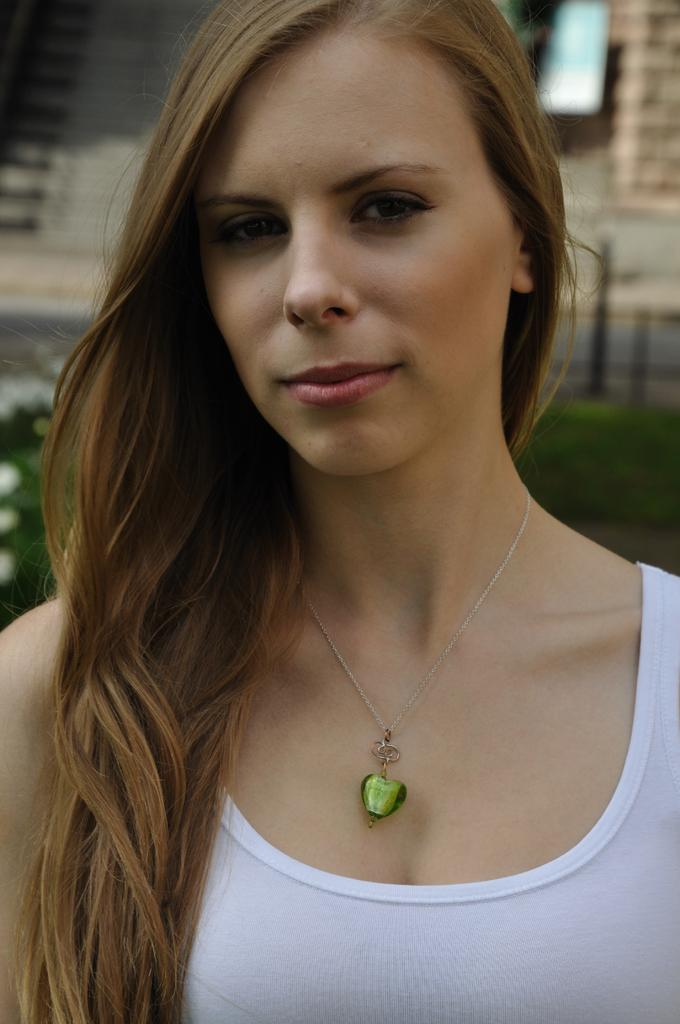Who is present in the image? There is a woman in the image. What is the woman doing in the image? The woman is standing in the image. What is the woman's facial expression in the image? The woman is smiling in the image. What accessory is the woman wearing in the image? The woman is wearing a locket in the image. What type of bomb is the woman holding in the image? There is no bomb present in the image; the woman is not holding any such object. 